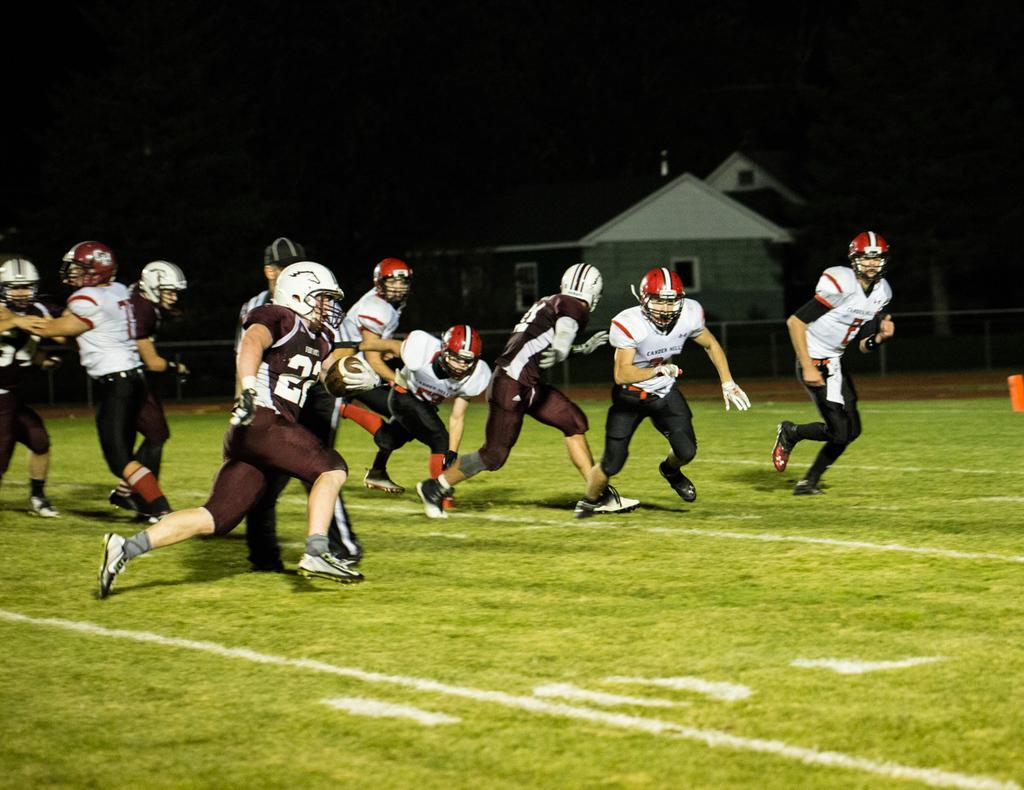In one or two sentences, can you explain what this image depicts? In this picture I can see few players on the ground and they wore helmets on their heads and I can see a house in the back and I can see a rugby ball in the hand of a player and I can see dark background. 